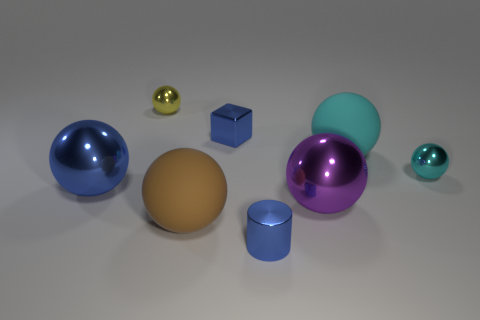Describe the lighting and shadows observed in this image and what mood it creates. The lighting in the image is soft and diffuse, creating gentle shadows and a calm, relaxed mood. The subtle interplay of light and shadow accentuates the objects' shapes and gives the scene a tranquil and almost ethereal quality. 